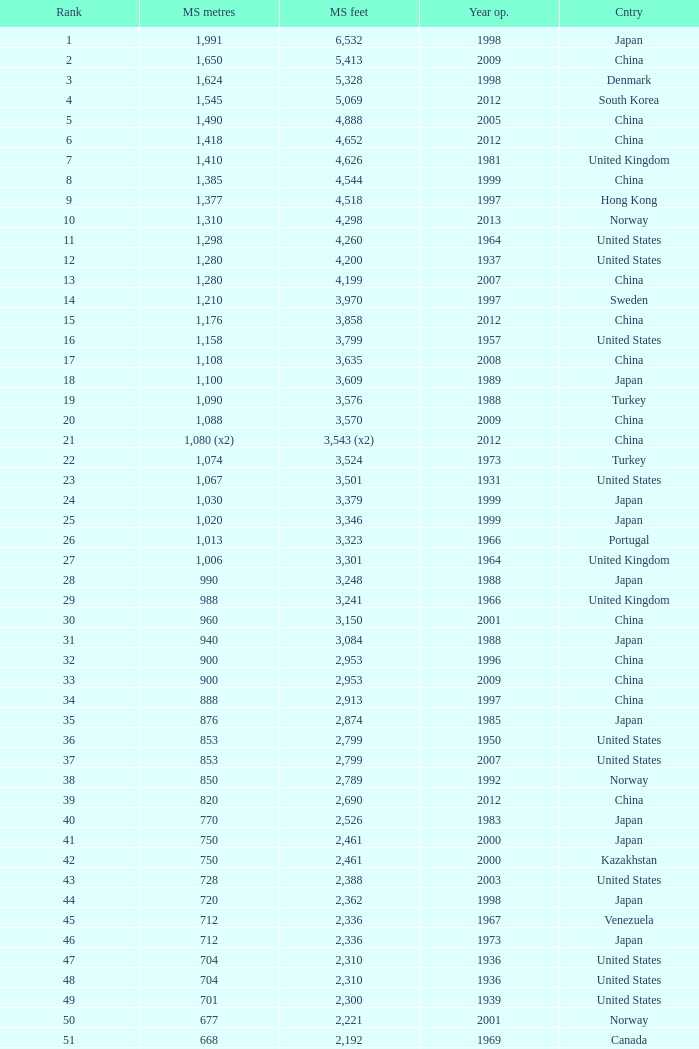What is the principal span distance in feet since the commencement year of 1936 in the united states, with a ranking higher than 47 and 421 main span meters? 1381.0. 